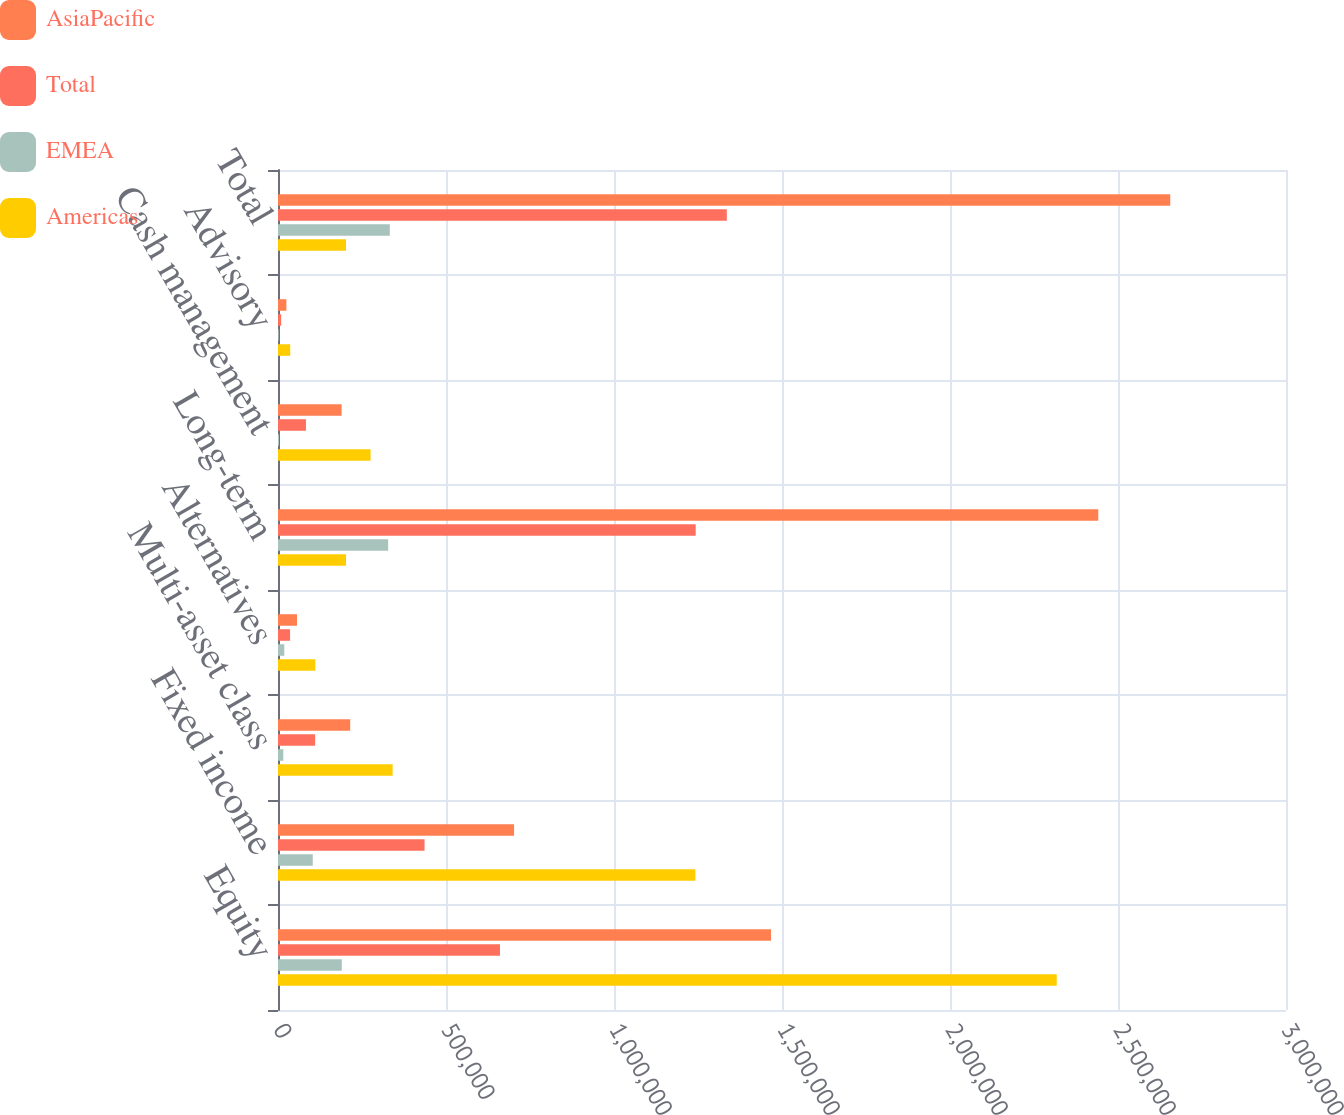Convert chart to OTSL. <chart><loc_0><loc_0><loc_500><loc_500><stacked_bar_chart><ecel><fcel>Equity<fcel>Fixed income<fcel>Multi-asset class<fcel>Alternatives<fcel>Long-term<fcel>Cash management<fcel>Advisory<fcel>Total<nl><fcel>AsiaPacific<fcel>1.46725e+06<fcel>702608<fcel>214895<fcel>56490<fcel>2.44124e+06<fcel>189359<fcel>24925<fcel>2.65553e+06<nl><fcel>Total<fcel>660602<fcel>436124<fcel>110524<fcel>35923<fcel>1.24317e+06<fcel>83207<fcel>9397<fcel>1.33578e+06<nl><fcel>EMEA<fcel>189841<fcel>103454<fcel>15795<fcel>18701<fcel>327791<fcel>2988<fcel>2003<fcel>332782<nl><fcel>Americas<fcel>2.3177e+06<fcel>1.24219e+06<fcel>341214<fcel>111114<fcel>202368<fcel>275554<fcel>36325<fcel>202368<nl></chart> 